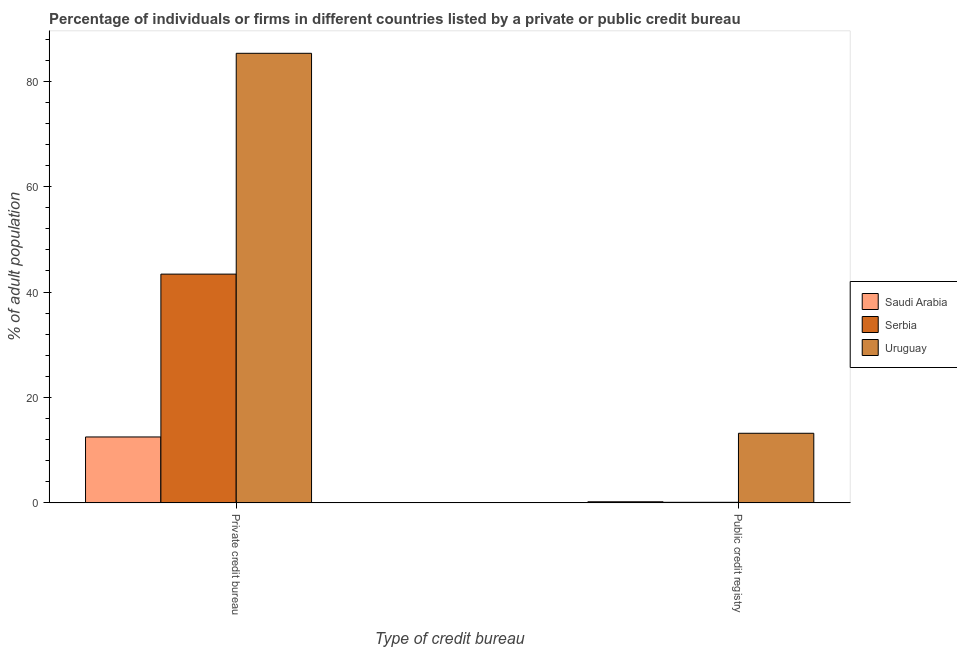How many different coloured bars are there?
Your answer should be very brief. 3. How many bars are there on the 2nd tick from the left?
Your response must be concise. 3. How many bars are there on the 2nd tick from the right?
Make the answer very short. 3. What is the label of the 2nd group of bars from the left?
Make the answer very short. Public credit registry. What is the percentage of firms listed by private credit bureau in Serbia?
Ensure brevity in your answer.  43.4. Across all countries, what is the maximum percentage of firms listed by private credit bureau?
Offer a terse response. 85.3. In which country was the percentage of firms listed by private credit bureau maximum?
Your response must be concise. Uruguay. In which country was the percentage of firms listed by public credit bureau minimum?
Provide a short and direct response. Serbia. What is the difference between the percentage of firms listed by private credit bureau in Serbia and that in Uruguay?
Provide a succinct answer. -41.9. What is the difference between the percentage of firms listed by private credit bureau in Saudi Arabia and the percentage of firms listed by public credit bureau in Uruguay?
Offer a terse response. -0.7. What is the average percentage of firms listed by public credit bureau per country?
Offer a very short reply. 4.5. What is the difference between the percentage of firms listed by public credit bureau and percentage of firms listed by private credit bureau in Saudi Arabia?
Your response must be concise. -12.3. What is the ratio of the percentage of firms listed by private credit bureau in Serbia to that in Uruguay?
Your answer should be very brief. 0.51. What does the 2nd bar from the left in Public credit registry represents?
Offer a terse response. Serbia. What does the 1st bar from the right in Private credit bureau represents?
Keep it short and to the point. Uruguay. How many bars are there?
Keep it short and to the point. 6. Are all the bars in the graph horizontal?
Offer a very short reply. No. What is the difference between two consecutive major ticks on the Y-axis?
Provide a short and direct response. 20. Are the values on the major ticks of Y-axis written in scientific E-notation?
Offer a very short reply. No. How many legend labels are there?
Ensure brevity in your answer.  3. What is the title of the graph?
Keep it short and to the point. Percentage of individuals or firms in different countries listed by a private or public credit bureau. What is the label or title of the X-axis?
Ensure brevity in your answer.  Type of credit bureau. What is the label or title of the Y-axis?
Make the answer very short. % of adult population. What is the % of adult population in Saudi Arabia in Private credit bureau?
Ensure brevity in your answer.  12.5. What is the % of adult population in Serbia in Private credit bureau?
Your response must be concise. 43.4. What is the % of adult population of Uruguay in Private credit bureau?
Your response must be concise. 85.3. What is the % of adult population of Serbia in Public credit registry?
Your answer should be compact. 0.1. Across all Type of credit bureau, what is the maximum % of adult population of Serbia?
Your response must be concise. 43.4. Across all Type of credit bureau, what is the maximum % of adult population of Uruguay?
Your answer should be very brief. 85.3. Across all Type of credit bureau, what is the minimum % of adult population of Saudi Arabia?
Provide a succinct answer. 0.2. Across all Type of credit bureau, what is the minimum % of adult population in Serbia?
Your answer should be compact. 0.1. Across all Type of credit bureau, what is the minimum % of adult population of Uruguay?
Keep it short and to the point. 13.2. What is the total % of adult population of Serbia in the graph?
Offer a terse response. 43.5. What is the total % of adult population of Uruguay in the graph?
Make the answer very short. 98.5. What is the difference between the % of adult population of Serbia in Private credit bureau and that in Public credit registry?
Your answer should be compact. 43.3. What is the difference between the % of adult population in Uruguay in Private credit bureau and that in Public credit registry?
Offer a terse response. 72.1. What is the difference between the % of adult population in Serbia in Private credit bureau and the % of adult population in Uruguay in Public credit registry?
Ensure brevity in your answer.  30.2. What is the average % of adult population in Saudi Arabia per Type of credit bureau?
Make the answer very short. 6.35. What is the average % of adult population of Serbia per Type of credit bureau?
Ensure brevity in your answer.  21.75. What is the average % of adult population of Uruguay per Type of credit bureau?
Provide a short and direct response. 49.25. What is the difference between the % of adult population of Saudi Arabia and % of adult population of Serbia in Private credit bureau?
Your response must be concise. -30.9. What is the difference between the % of adult population of Saudi Arabia and % of adult population of Uruguay in Private credit bureau?
Your answer should be very brief. -72.8. What is the difference between the % of adult population of Serbia and % of adult population of Uruguay in Private credit bureau?
Your answer should be very brief. -41.9. What is the difference between the % of adult population in Saudi Arabia and % of adult population in Serbia in Public credit registry?
Keep it short and to the point. 0.1. What is the difference between the % of adult population of Serbia and % of adult population of Uruguay in Public credit registry?
Offer a very short reply. -13.1. What is the ratio of the % of adult population of Saudi Arabia in Private credit bureau to that in Public credit registry?
Ensure brevity in your answer.  62.5. What is the ratio of the % of adult population of Serbia in Private credit bureau to that in Public credit registry?
Give a very brief answer. 434. What is the ratio of the % of adult population in Uruguay in Private credit bureau to that in Public credit registry?
Keep it short and to the point. 6.46. What is the difference between the highest and the second highest % of adult population in Serbia?
Your response must be concise. 43.3. What is the difference between the highest and the second highest % of adult population of Uruguay?
Provide a succinct answer. 72.1. What is the difference between the highest and the lowest % of adult population of Serbia?
Give a very brief answer. 43.3. What is the difference between the highest and the lowest % of adult population in Uruguay?
Provide a succinct answer. 72.1. 